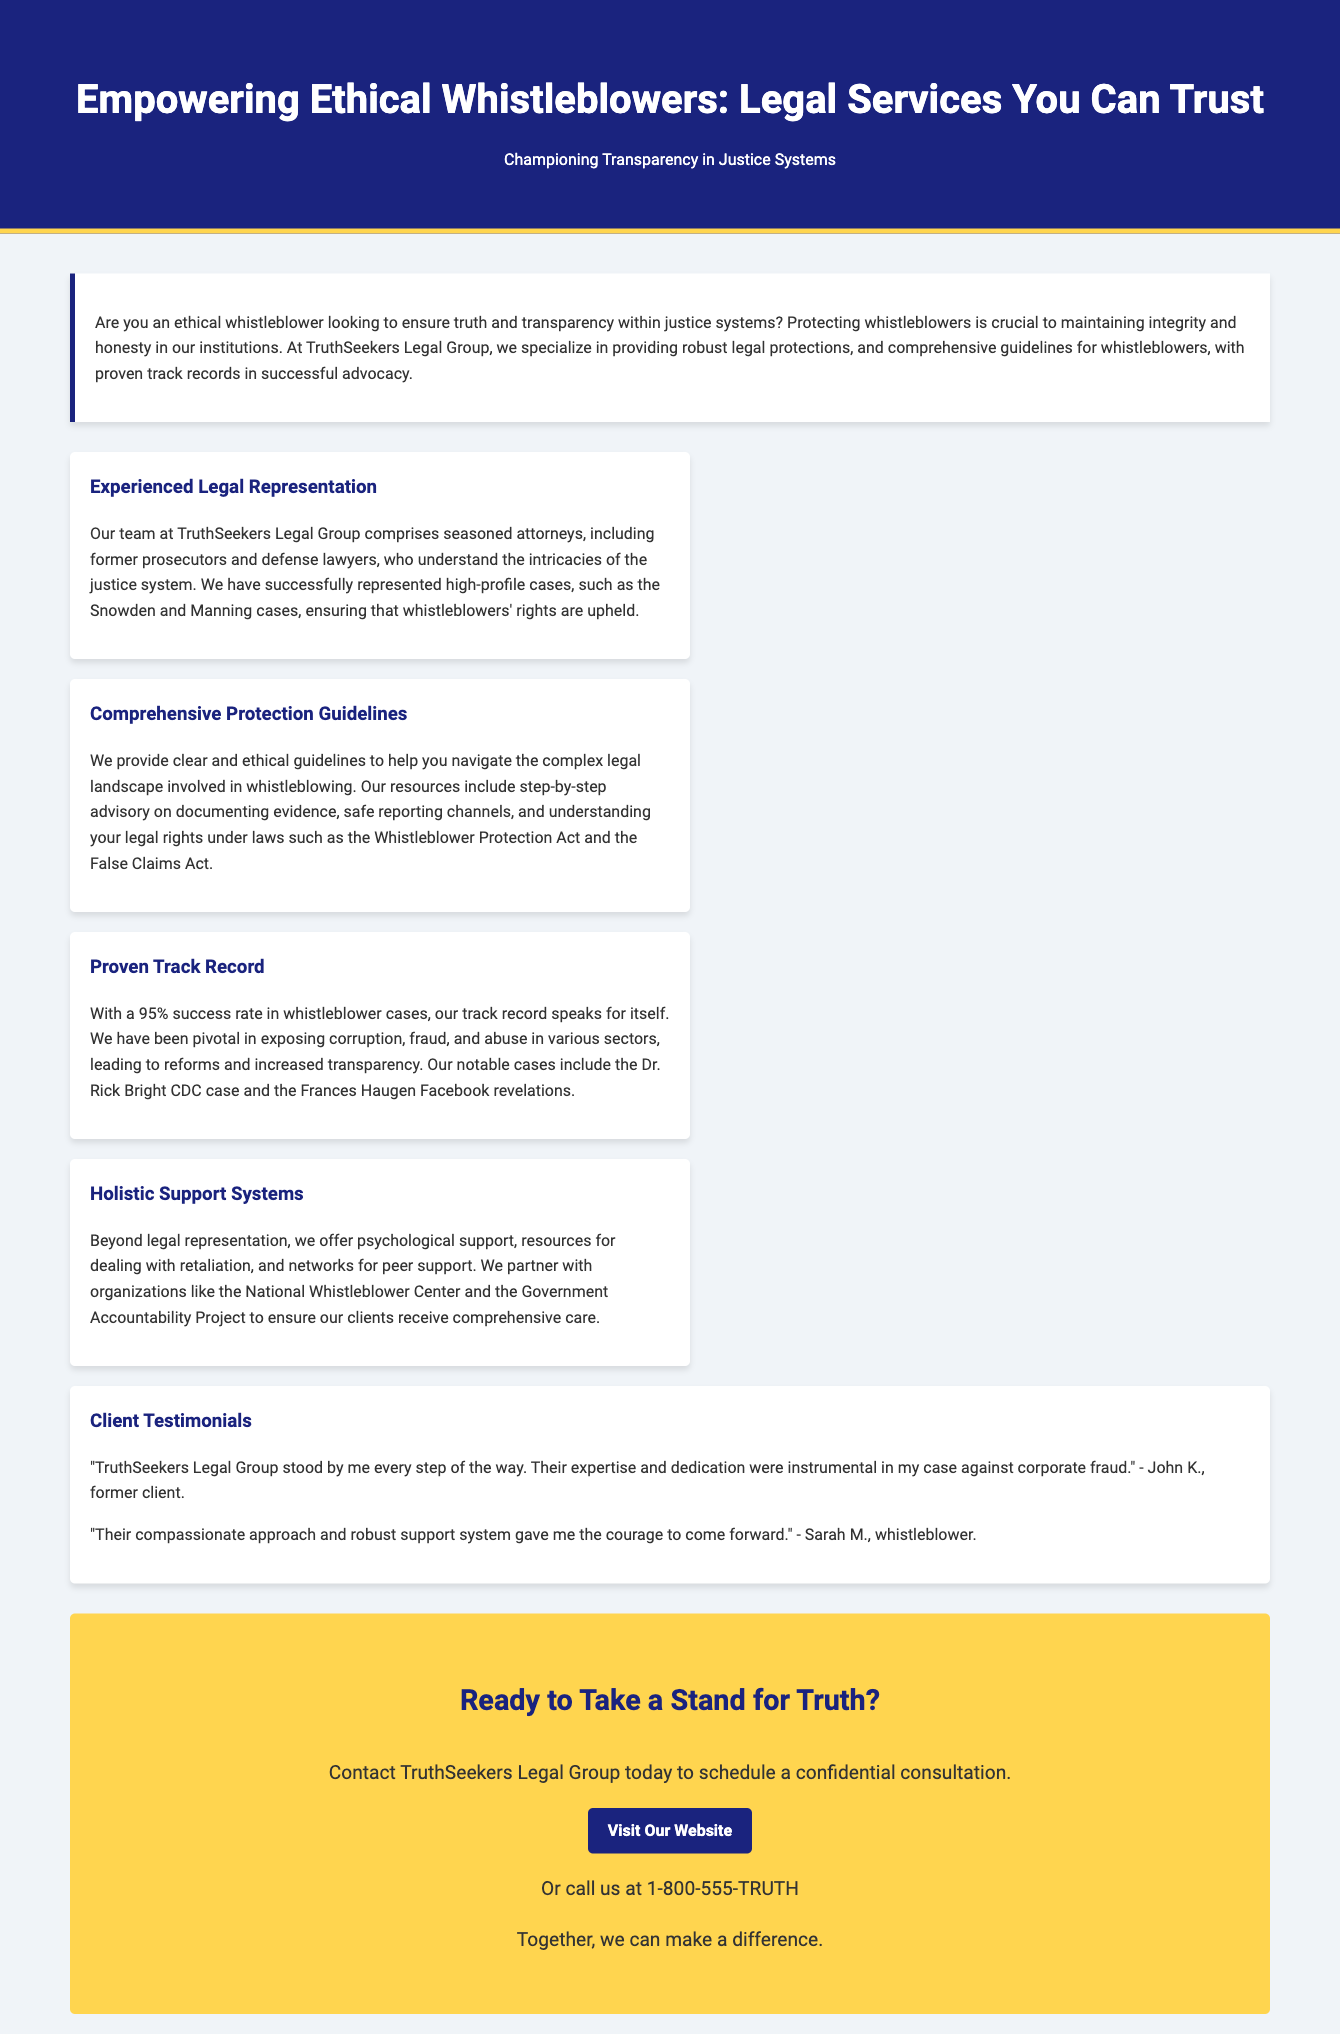What is the name of the legal group providing whistleblower protection? The document mentions that the legal group providing whistleblower protection is called TruthSeekers Legal Group.
Answer: TruthSeekers Legal Group What is the success rate in whistleblower cases? The document states that TruthSeekers Legal Group has a 95% success rate in whistleblower cases.
Answer: 95% Who are some notable cases mentioned in the document? The document lists the Snowden, Manning, Dr. Rick Bright CDC case, and Frances Haugen Facebook revelations as notable cases.
Answer: Snowden, Manning, Dr. Rick Bright, Frances Haugen What type of support systems does the legal group offer besides legal representation? The document mentions that the legal group offers psychological support, resources for dealing with retaliation, and peer support networks.
Answer: Psychological support, resources, peer support What call to action is presented at the end of the advertisement? The advertisement concludes with a call to action encouraging readers to contact TruthSeekers Legal Group for a confidential consultation.
Answer: Contact TruthSeekers Legal Group today What is promoted as a critical factor for transparency in justice systems? The document emphasizes that protecting whistleblowers is crucial to maintaining integrity and honesty in institutions.
Answer: Protecting whistleblowers How does the document refer to its lawyers' backgrounds? The document describes the lawyers as seasoned attorneys, including former prosecutors and defense lawyers.
Answer: Seasoned attorneys, former prosecutors, defense lawyers 